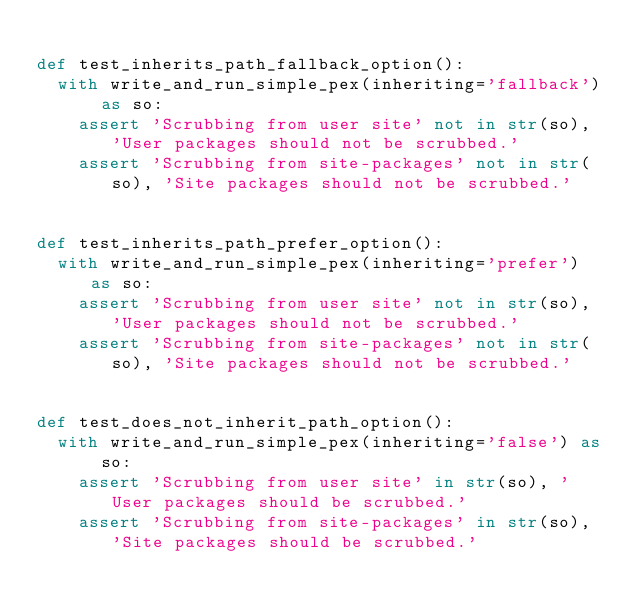<code> <loc_0><loc_0><loc_500><loc_500><_Python_>
def test_inherits_path_fallback_option():
  with write_and_run_simple_pex(inheriting='fallback') as so:
    assert 'Scrubbing from user site' not in str(so), 'User packages should not be scrubbed.'
    assert 'Scrubbing from site-packages' not in str(so), 'Site packages should not be scrubbed.'


def test_inherits_path_prefer_option():
  with write_and_run_simple_pex(inheriting='prefer') as so:
    assert 'Scrubbing from user site' not in str(so), 'User packages should not be scrubbed.'
    assert 'Scrubbing from site-packages' not in str(so), 'Site packages should not be scrubbed.'


def test_does_not_inherit_path_option():
  with write_and_run_simple_pex(inheriting='false') as so:
    assert 'Scrubbing from user site' in str(so), 'User packages should be scrubbed.'
    assert 'Scrubbing from site-packages' in str(so), 'Site packages should be scrubbed.'
</code> 